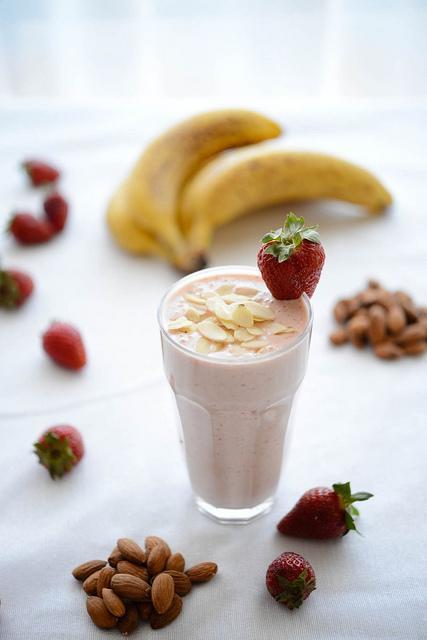How many bananas are there?
Give a very brief answer. 3. How many bananas are visible?
Give a very brief answer. 3. How many people are wearing a orange shirt?
Give a very brief answer. 0. 